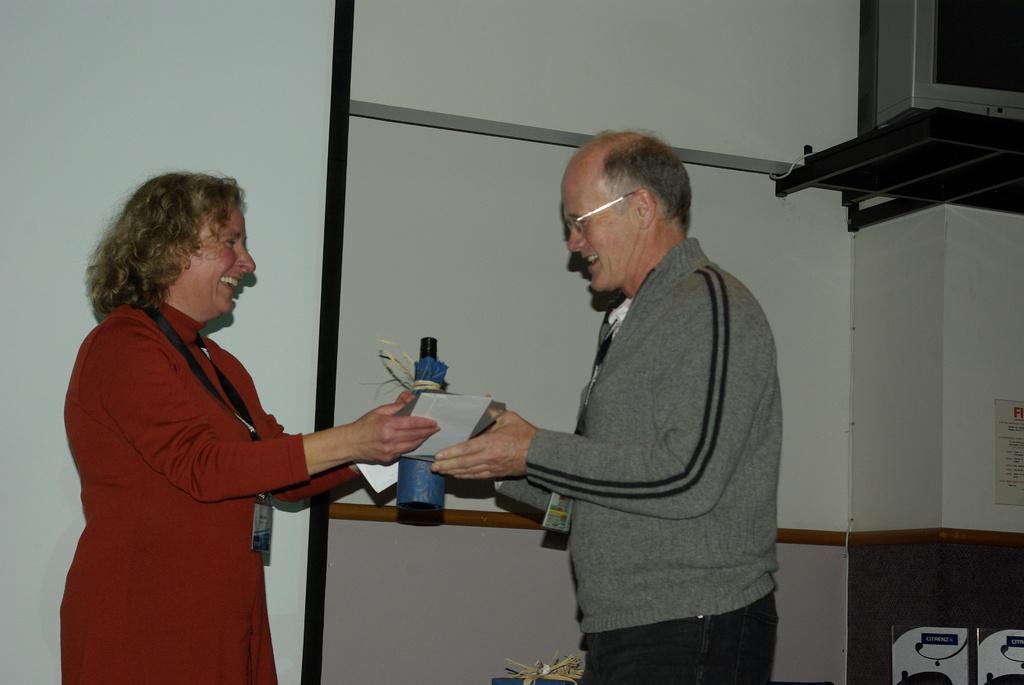Please provide a concise description of this image. This picture shows a woman standing and holding some papers in the hand and giving to a man we see man taking papers from the woman and a wine bottle and we see man wore a spectacles on his face and a ID card and we see woman with ID card and smile on their faces and we see a television on the stand. 